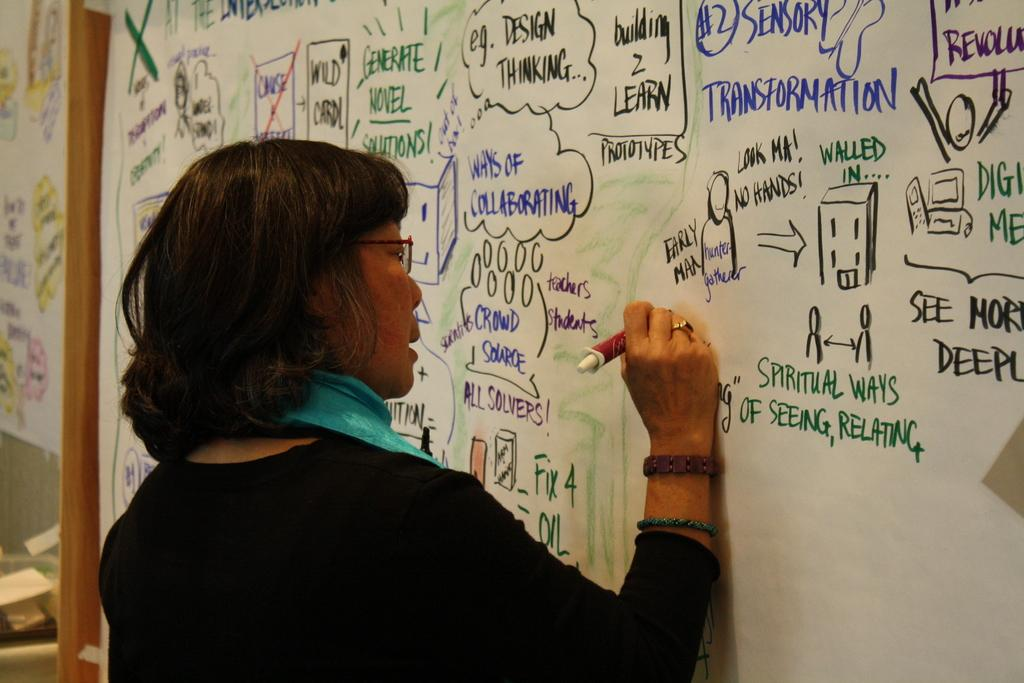<image>
Render a clear and concise summary of the photo. A woman is writing on a white board that has the word transformation written on it 